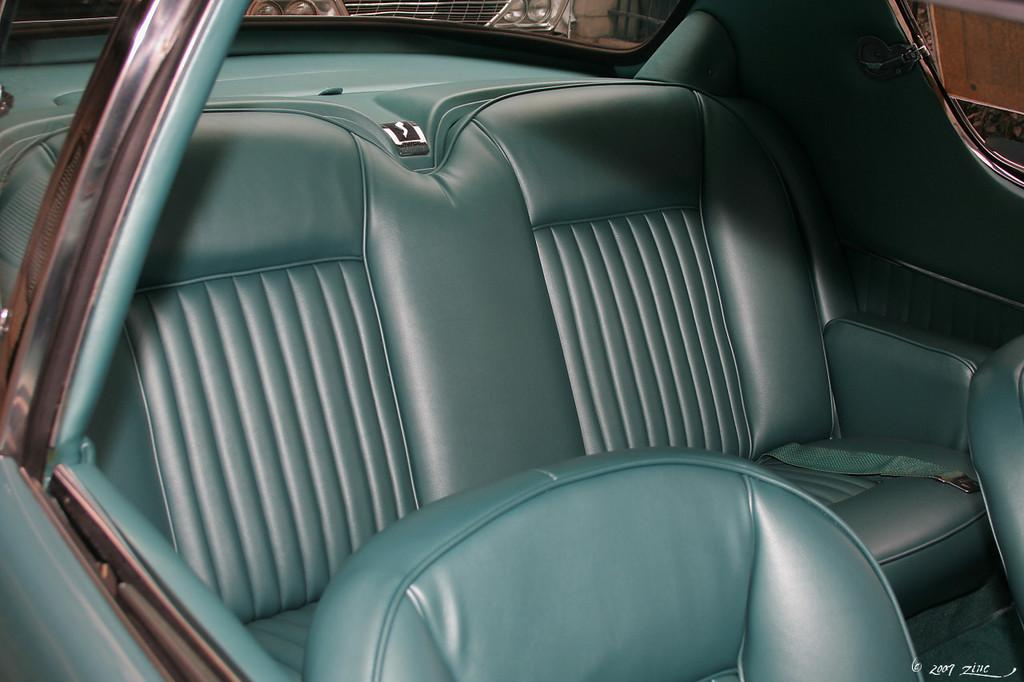What type of setting is depicted in the image? The image contains the interiors of a car. Can you describe any other vehicles visible in the image? There are cars visible in the background of the image. What type of cemetery can be seen in the background of the image? There is no cemetery present in the image; it depicts the interiors of a car and cars in the background. 